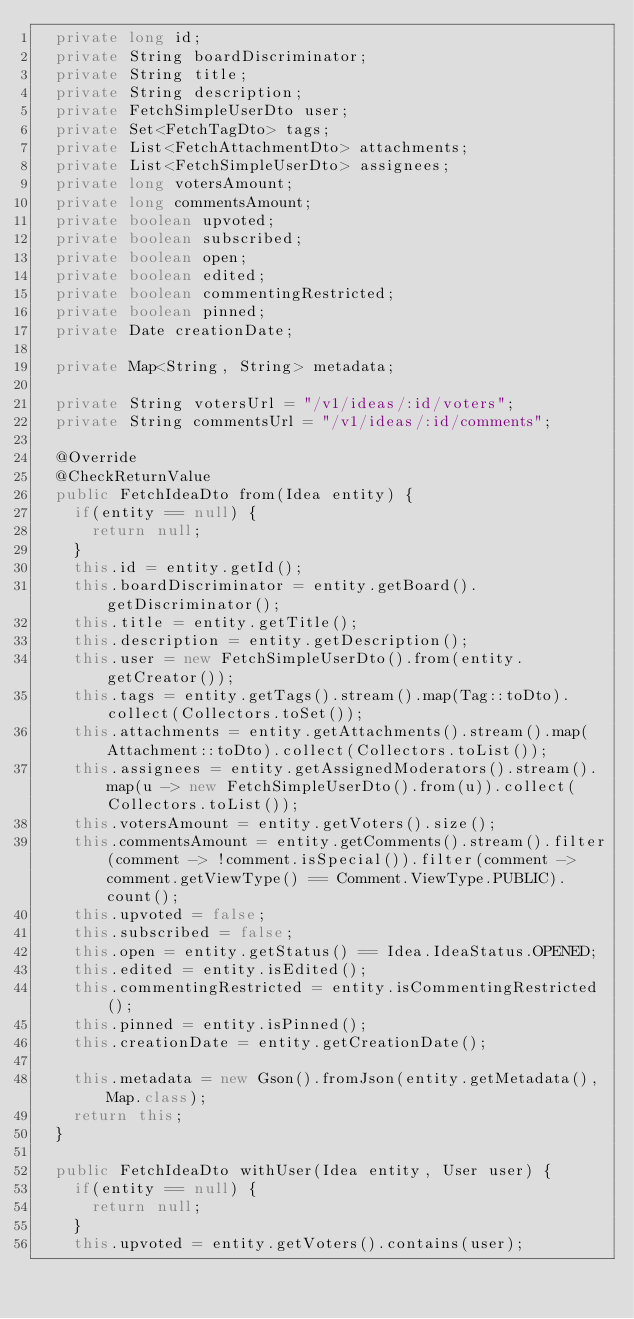Convert code to text. <code><loc_0><loc_0><loc_500><loc_500><_Java_>  private long id;
  private String boardDiscriminator;
  private String title;
  private String description;
  private FetchSimpleUserDto user;
  private Set<FetchTagDto> tags;
  private List<FetchAttachmentDto> attachments;
  private List<FetchSimpleUserDto> assignees;
  private long votersAmount;
  private long commentsAmount;
  private boolean upvoted;
  private boolean subscribed;
  private boolean open;
  private boolean edited;
  private boolean commentingRestricted;
  private boolean pinned;
  private Date creationDate;

  private Map<String, String> metadata;

  private String votersUrl = "/v1/ideas/:id/voters";
  private String commentsUrl = "/v1/ideas/:id/comments";

  @Override
  @CheckReturnValue
  public FetchIdeaDto from(Idea entity) {
    if(entity == null) {
      return null;
    }
    this.id = entity.getId();
    this.boardDiscriminator = entity.getBoard().getDiscriminator();
    this.title = entity.getTitle();
    this.description = entity.getDescription();
    this.user = new FetchSimpleUserDto().from(entity.getCreator());
    this.tags = entity.getTags().stream().map(Tag::toDto).collect(Collectors.toSet());
    this.attachments = entity.getAttachments().stream().map(Attachment::toDto).collect(Collectors.toList());
    this.assignees = entity.getAssignedModerators().stream().map(u -> new FetchSimpleUserDto().from(u)).collect(Collectors.toList());
    this.votersAmount = entity.getVoters().size();
    this.commentsAmount = entity.getComments().stream().filter(comment -> !comment.isSpecial()).filter(comment -> comment.getViewType() == Comment.ViewType.PUBLIC).count();
    this.upvoted = false;
    this.subscribed = false;
    this.open = entity.getStatus() == Idea.IdeaStatus.OPENED;
    this.edited = entity.isEdited();
    this.commentingRestricted = entity.isCommentingRestricted();
    this.pinned = entity.isPinned();
    this.creationDate = entity.getCreationDate();

    this.metadata = new Gson().fromJson(entity.getMetadata(), Map.class);
    return this;
  }

  public FetchIdeaDto withUser(Idea entity, User user) {
    if(entity == null) {
      return null;
    }
    this.upvoted = entity.getVoters().contains(user);</code> 